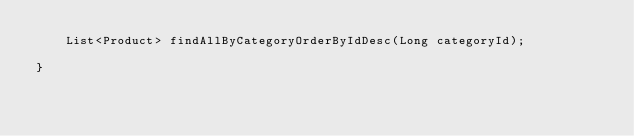Convert code to text. <code><loc_0><loc_0><loc_500><loc_500><_Java_>    List<Product> findAllByCategoryOrderByIdDesc(Long categoryId);

}
</code> 